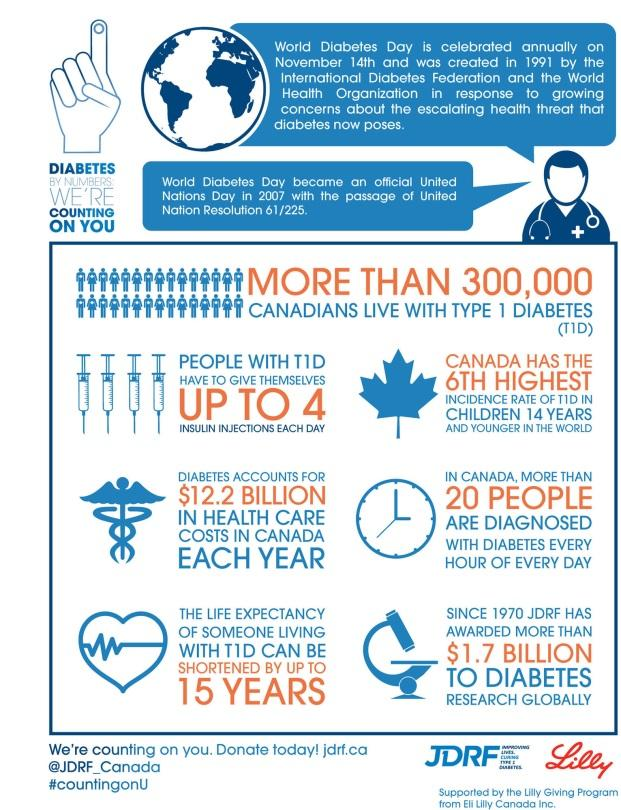Highlight a few significant elements in this photo. Canada ranks sixth in the number of children aged 14 and younger who have Type 1 diabetes. People with Type 1 Diabetes typically take an average of 1-4 insulin injections per day to manage their condition. 